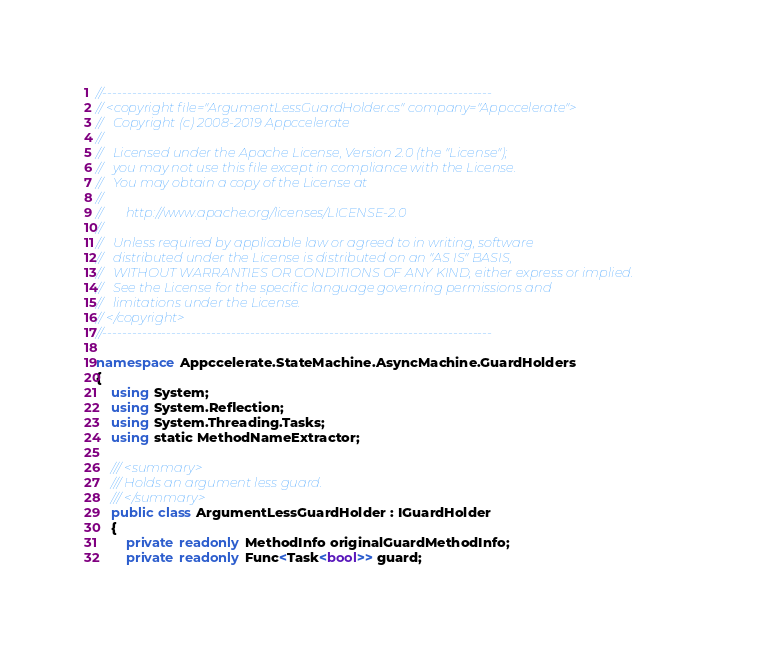Convert code to text. <code><loc_0><loc_0><loc_500><loc_500><_C#_>//-------------------------------------------------------------------------------
// <copyright file="ArgumentLessGuardHolder.cs" company="Appccelerate">
//   Copyright (c) 2008-2019 Appccelerate
//
//   Licensed under the Apache License, Version 2.0 (the "License");
//   you may not use this file except in compliance with the License.
//   You may obtain a copy of the License at
//
//       http://www.apache.org/licenses/LICENSE-2.0
//
//   Unless required by applicable law or agreed to in writing, software
//   distributed under the License is distributed on an "AS IS" BASIS,
//   WITHOUT WARRANTIES OR CONDITIONS OF ANY KIND, either express or implied.
//   See the License for the specific language governing permissions and
//   limitations under the License.
// </copyright>
//-------------------------------------------------------------------------------

namespace Appccelerate.StateMachine.AsyncMachine.GuardHolders
{
    using System;
    using System.Reflection;
    using System.Threading.Tasks;
    using static MethodNameExtractor;

    /// <summary>
    /// Holds an argument less guard.
    /// </summary>
    public class ArgumentLessGuardHolder : IGuardHolder
    {
        private readonly MethodInfo originalGuardMethodInfo;
        private readonly Func<Task<bool>> guard;
</code> 